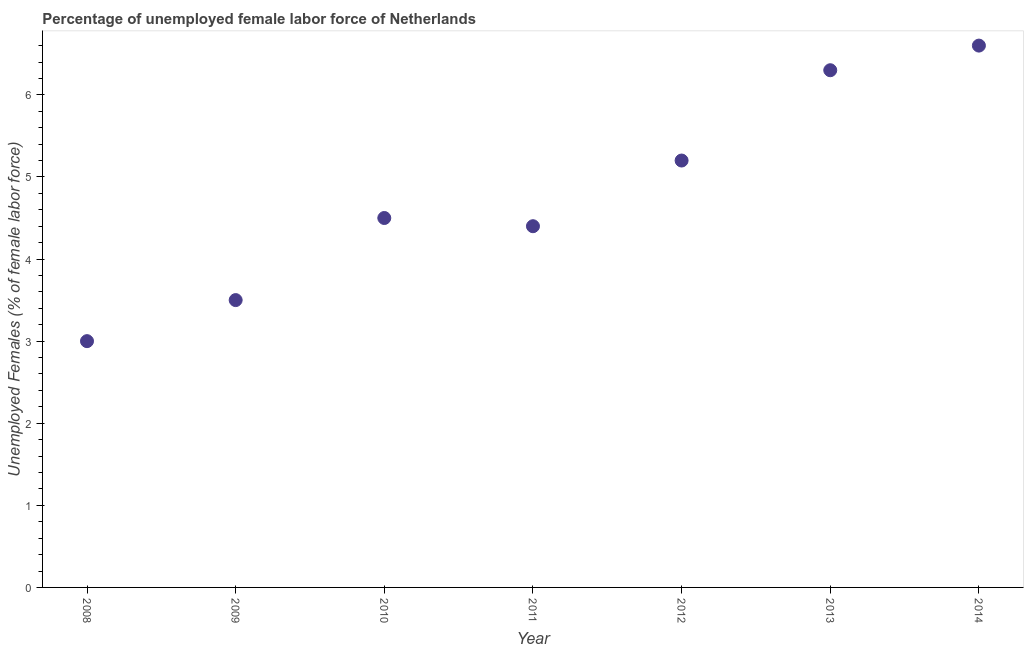What is the total unemployed female labour force in 2008?
Your answer should be very brief. 3. Across all years, what is the maximum total unemployed female labour force?
Ensure brevity in your answer.  6.6. In which year was the total unemployed female labour force minimum?
Keep it short and to the point. 2008. What is the sum of the total unemployed female labour force?
Give a very brief answer. 33.5. What is the difference between the total unemployed female labour force in 2012 and 2013?
Ensure brevity in your answer.  -1.1. What is the average total unemployed female labour force per year?
Your response must be concise. 4.79. What is the median total unemployed female labour force?
Offer a terse response. 4.5. Do a majority of the years between 2012 and 2011 (inclusive) have total unemployed female labour force greater than 0.8 %?
Make the answer very short. No. What is the ratio of the total unemployed female labour force in 2008 to that in 2014?
Offer a terse response. 0.45. What is the difference between the highest and the second highest total unemployed female labour force?
Offer a very short reply. 0.3. Is the sum of the total unemployed female labour force in 2008 and 2010 greater than the maximum total unemployed female labour force across all years?
Offer a very short reply. Yes. What is the difference between the highest and the lowest total unemployed female labour force?
Offer a very short reply. 3.6. How many dotlines are there?
Provide a succinct answer. 1. How many years are there in the graph?
Your response must be concise. 7. What is the difference between two consecutive major ticks on the Y-axis?
Offer a terse response. 1. Are the values on the major ticks of Y-axis written in scientific E-notation?
Make the answer very short. No. Does the graph contain any zero values?
Your answer should be compact. No. What is the title of the graph?
Ensure brevity in your answer.  Percentage of unemployed female labor force of Netherlands. What is the label or title of the Y-axis?
Your response must be concise. Unemployed Females (% of female labor force). What is the Unemployed Females (% of female labor force) in 2008?
Your response must be concise. 3. What is the Unemployed Females (% of female labor force) in 2009?
Your answer should be compact. 3.5. What is the Unemployed Females (% of female labor force) in 2011?
Your response must be concise. 4.4. What is the Unemployed Females (% of female labor force) in 2012?
Your response must be concise. 5.2. What is the Unemployed Females (% of female labor force) in 2013?
Offer a very short reply. 6.3. What is the Unemployed Females (% of female labor force) in 2014?
Offer a terse response. 6.6. What is the difference between the Unemployed Females (% of female labor force) in 2008 and 2009?
Keep it short and to the point. -0.5. What is the difference between the Unemployed Females (% of female labor force) in 2008 and 2011?
Your answer should be very brief. -1.4. What is the difference between the Unemployed Females (% of female labor force) in 2008 and 2012?
Ensure brevity in your answer.  -2.2. What is the difference between the Unemployed Females (% of female labor force) in 2009 and 2013?
Give a very brief answer. -2.8. What is the difference between the Unemployed Females (% of female labor force) in 2009 and 2014?
Your answer should be compact. -3.1. What is the difference between the Unemployed Females (% of female labor force) in 2010 and 2012?
Give a very brief answer. -0.7. What is the difference between the Unemployed Females (% of female labor force) in 2011 and 2012?
Ensure brevity in your answer.  -0.8. What is the difference between the Unemployed Females (% of female labor force) in 2011 and 2014?
Your answer should be very brief. -2.2. What is the difference between the Unemployed Females (% of female labor force) in 2012 and 2013?
Your answer should be very brief. -1.1. What is the difference between the Unemployed Females (% of female labor force) in 2012 and 2014?
Ensure brevity in your answer.  -1.4. What is the ratio of the Unemployed Females (% of female labor force) in 2008 to that in 2009?
Your answer should be compact. 0.86. What is the ratio of the Unemployed Females (% of female labor force) in 2008 to that in 2010?
Keep it short and to the point. 0.67. What is the ratio of the Unemployed Females (% of female labor force) in 2008 to that in 2011?
Offer a very short reply. 0.68. What is the ratio of the Unemployed Females (% of female labor force) in 2008 to that in 2012?
Provide a short and direct response. 0.58. What is the ratio of the Unemployed Females (% of female labor force) in 2008 to that in 2013?
Provide a succinct answer. 0.48. What is the ratio of the Unemployed Females (% of female labor force) in 2008 to that in 2014?
Make the answer very short. 0.46. What is the ratio of the Unemployed Females (% of female labor force) in 2009 to that in 2010?
Give a very brief answer. 0.78. What is the ratio of the Unemployed Females (% of female labor force) in 2009 to that in 2011?
Provide a short and direct response. 0.8. What is the ratio of the Unemployed Females (% of female labor force) in 2009 to that in 2012?
Your answer should be very brief. 0.67. What is the ratio of the Unemployed Females (% of female labor force) in 2009 to that in 2013?
Offer a terse response. 0.56. What is the ratio of the Unemployed Females (% of female labor force) in 2009 to that in 2014?
Give a very brief answer. 0.53. What is the ratio of the Unemployed Females (% of female labor force) in 2010 to that in 2012?
Provide a short and direct response. 0.86. What is the ratio of the Unemployed Females (% of female labor force) in 2010 to that in 2013?
Keep it short and to the point. 0.71. What is the ratio of the Unemployed Females (% of female labor force) in 2010 to that in 2014?
Keep it short and to the point. 0.68. What is the ratio of the Unemployed Females (% of female labor force) in 2011 to that in 2012?
Your answer should be compact. 0.85. What is the ratio of the Unemployed Females (% of female labor force) in 2011 to that in 2013?
Your answer should be very brief. 0.7. What is the ratio of the Unemployed Females (% of female labor force) in 2011 to that in 2014?
Provide a succinct answer. 0.67. What is the ratio of the Unemployed Females (% of female labor force) in 2012 to that in 2013?
Your answer should be very brief. 0.82. What is the ratio of the Unemployed Females (% of female labor force) in 2012 to that in 2014?
Offer a very short reply. 0.79. What is the ratio of the Unemployed Females (% of female labor force) in 2013 to that in 2014?
Offer a very short reply. 0.95. 